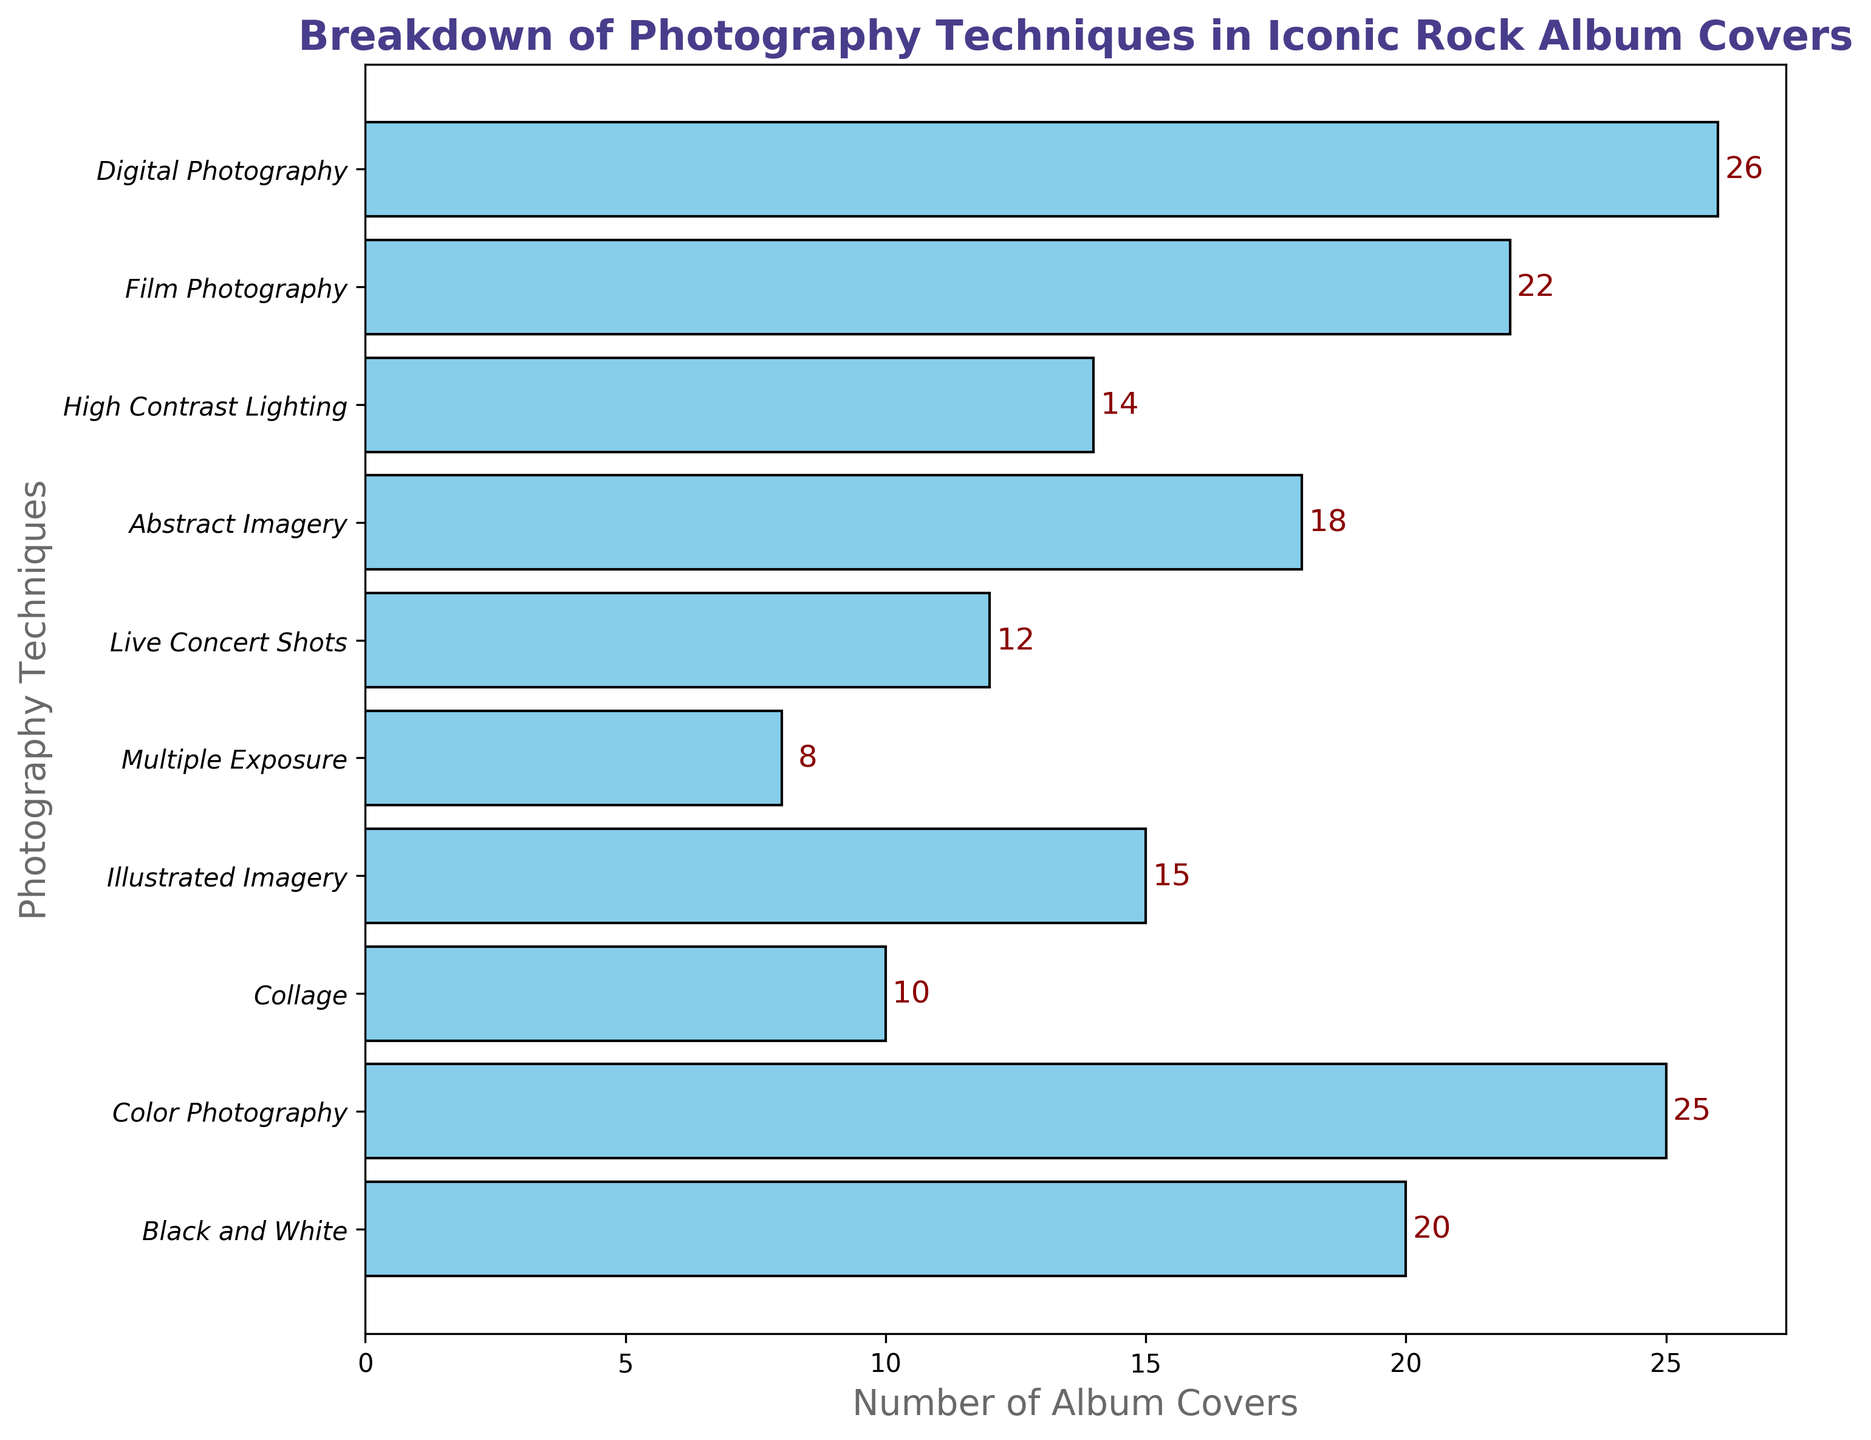What's the most commonly used photography technique for iconic rock album covers? The bar for "Digital Photography" is the longest in the chart, indicating it has the highest count.
Answer: Digital Photography Which two techniques have the closest usage count? "High Contrast Lighting" has 14, and "Live Concert Shots" has 12. The difference between them is 2, which is the smallest difference between any two techniques in the list.
Answer: High Contrast Lighting and Live Concert Shots What's the total number of album covers using Collage and Illustrated Imagery combined? Add the counts of "Collage" (10) and "Illustrated Imagery" (15). 10 + 15 = 25
Answer: 25 How does the usage of Black and White compare to Film Photography? "Black and White" has 20, and "Film Photography" has 22. Film Photography is slightly more common.
Answer: Film Photography is more common Which technique has a usage count exactly double that of Multiple Exposure? "Multiple Exposure" has 8, and doubling this count gives 16. None of the techniques have this exact count. Thus, no technique usage is exactly double that of Multiple Exposure.
Answer: None What is the average number of album covers for the listed photography techniques? Sum the counts (20+25+10+15+8+12+18+14+22+26 = 170) and divide by the number of techniques (10). 170 / 10 = 17
Answer: 17 What's the difference in count between the least and most used techniques? The least used technique is "Multiple Exposure" with 8, and the most used is "Digital Photography" with 26. 26 - 8 = 18
Answer: 18 Is there a technique with at least 30 album covers? All counts are below 30, as seen from the maximum count which is 26 for "Digital Photography".
Answer: No Which photography technique has a count closest to the overall average? The average count is 17. "Abstract Imagery" has 18, which is the closest to 17.
Answer: Abstract Imagery How many techniques have a count greater than 20? The chart shows that "Color Photography" (25), "Film Photography" (22), and "Digital Photography" (26) all have counts greater than 20. There are 3 techniques in total.
Answer: 3 